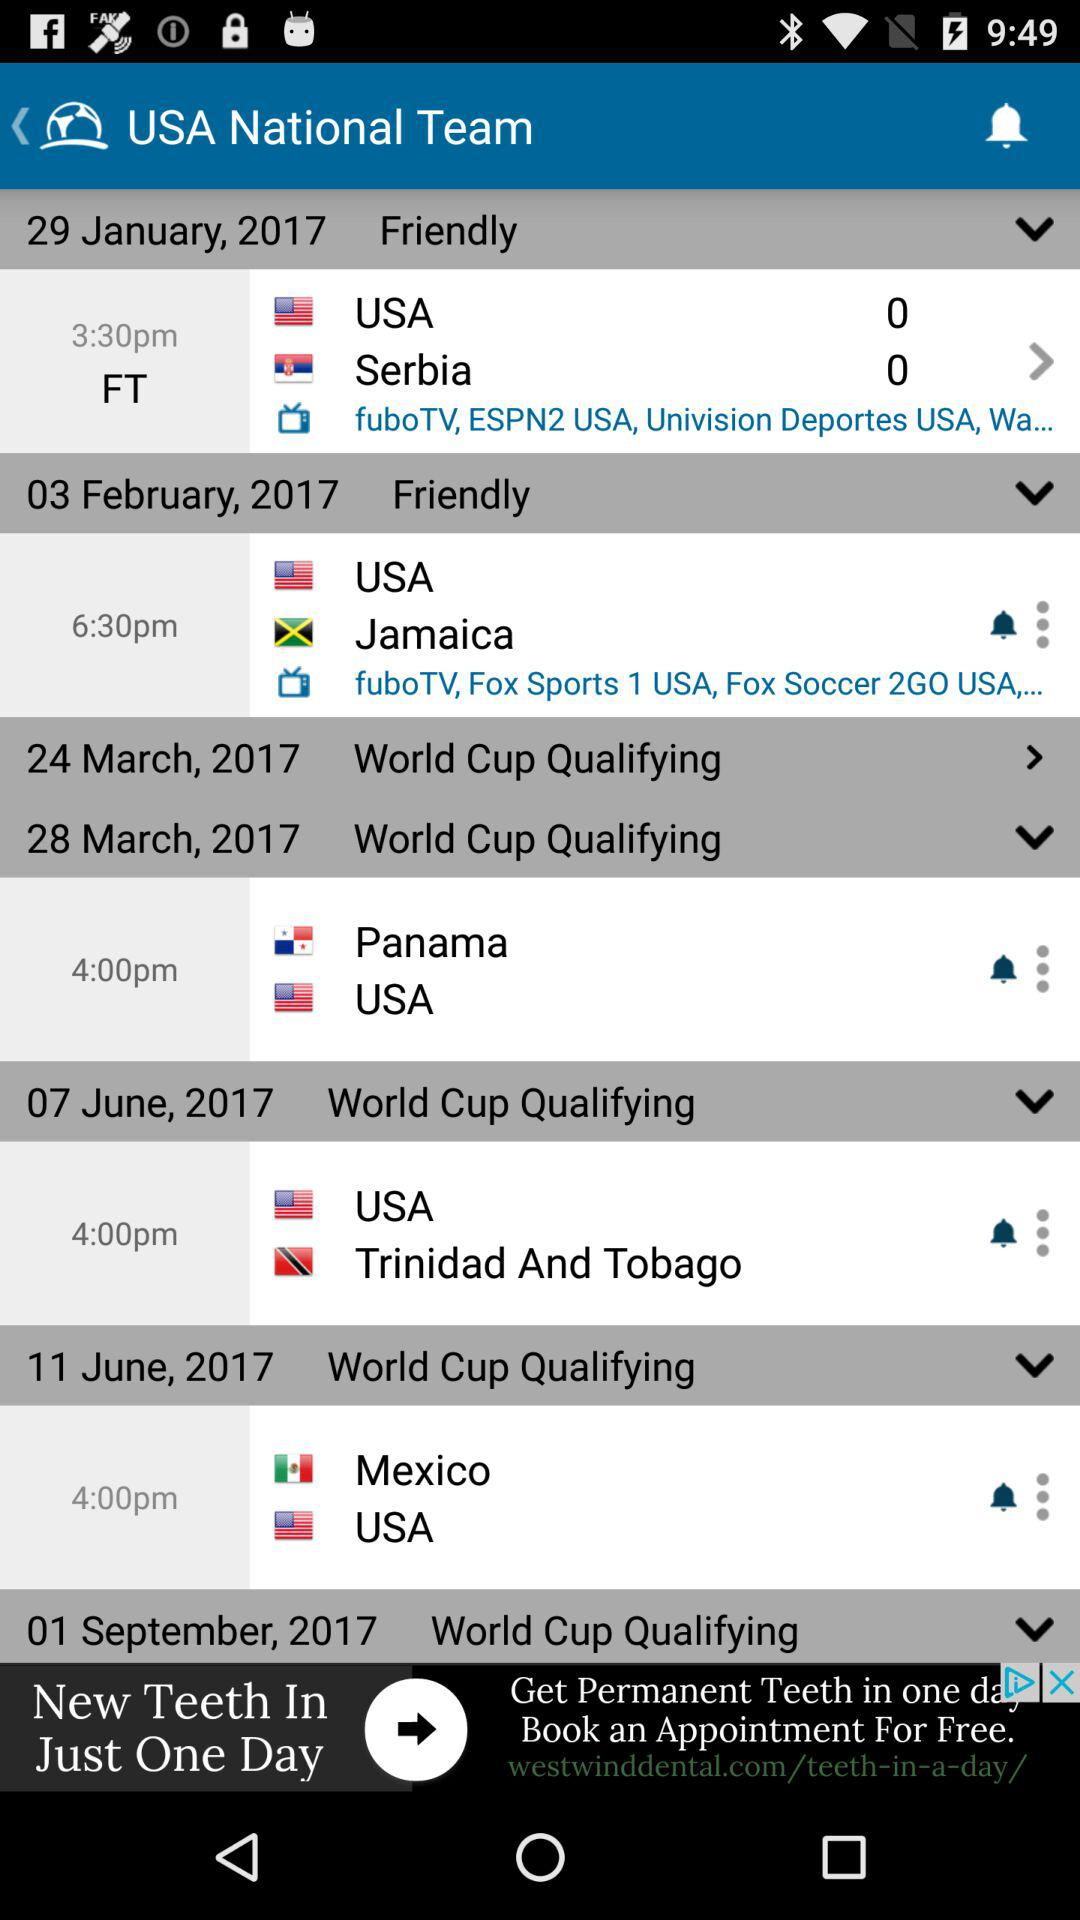How many matches are in the World Cup Qualifying section?
Answer the question using a single word or phrase. 4 